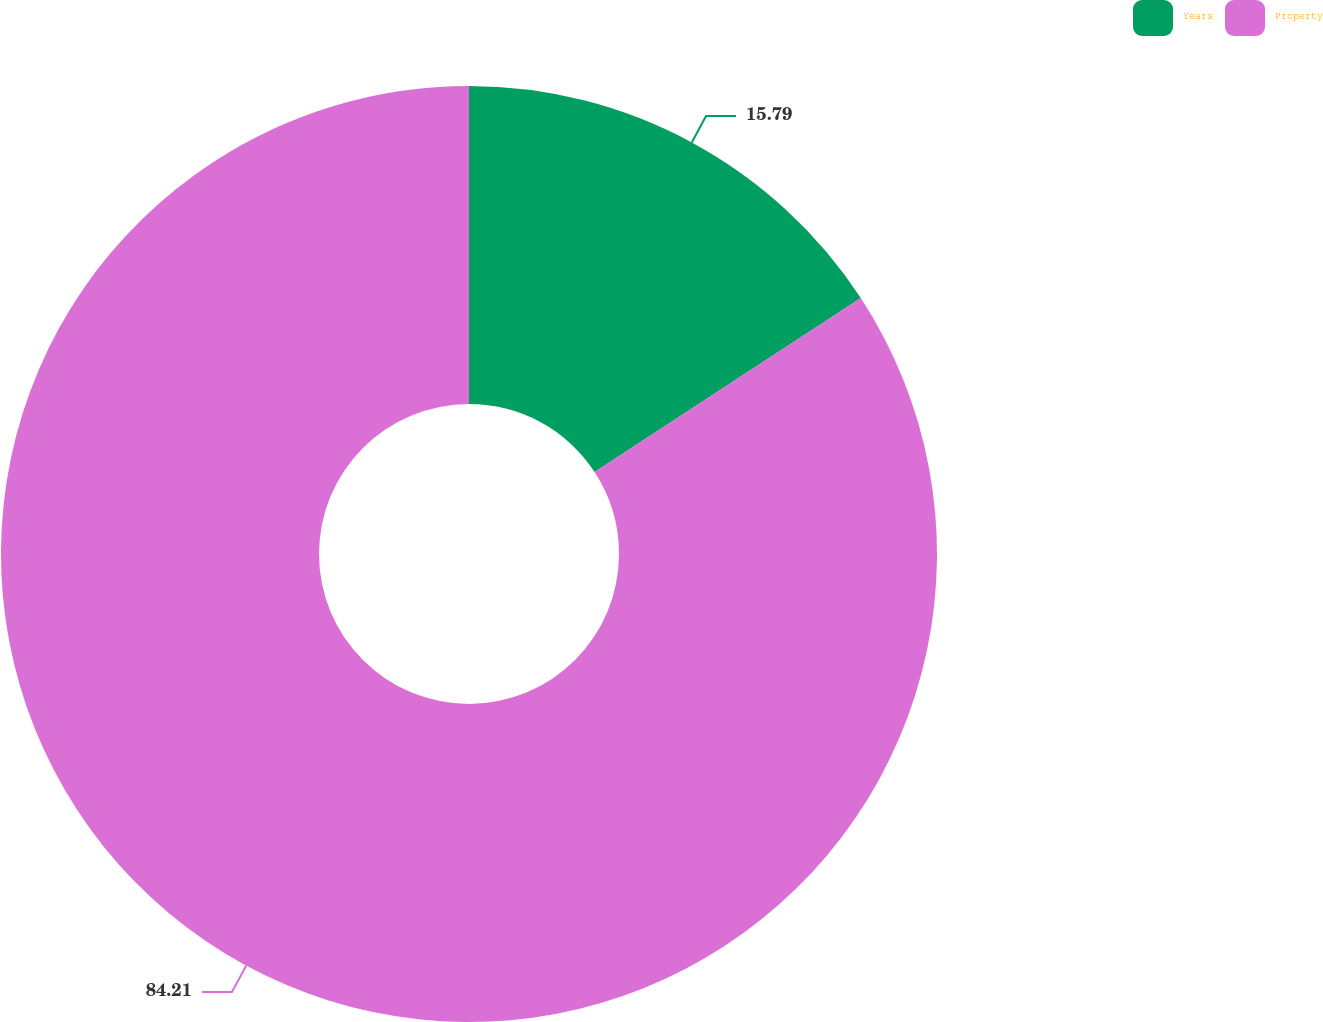<chart> <loc_0><loc_0><loc_500><loc_500><pie_chart><fcel>Years<fcel>Property<nl><fcel>15.79%<fcel>84.21%<nl></chart> 